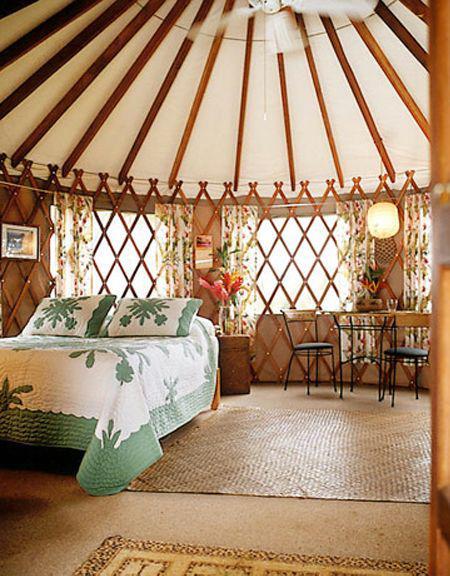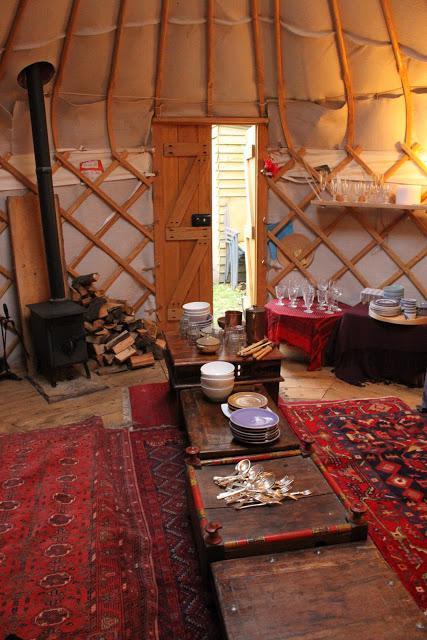The first image is the image on the left, the second image is the image on the right. Considering the images on both sides, is "There is a bed in the image on the right." valid? Answer yes or no. No. 